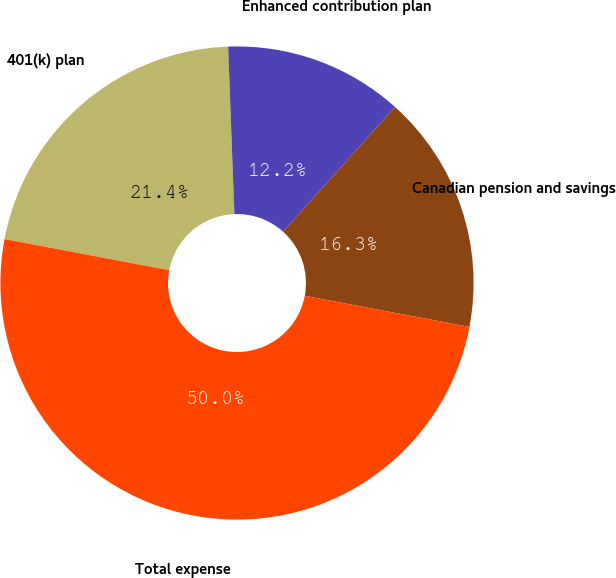<chart> <loc_0><loc_0><loc_500><loc_500><pie_chart><fcel>401(k) plan<fcel>Enhanced contribution plan<fcel>Canadian pension and savings<fcel>Total expense<nl><fcel>21.43%<fcel>12.24%<fcel>16.33%<fcel>50.0%<nl></chart> 